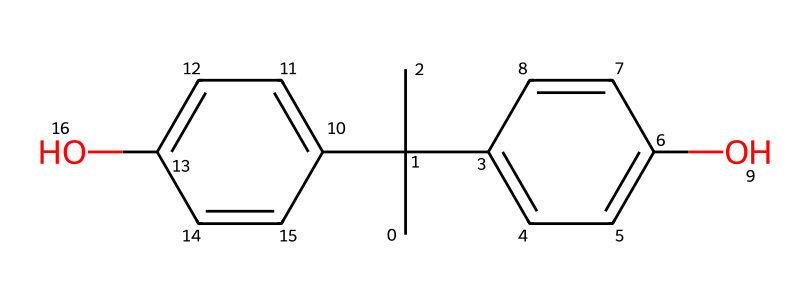what is the molecular formula of Bisphenol A? To determine the molecular formula, we can count the different atoms represented in the SMILES structure. There are 15 carbon (C) atoms, 16 hydrogen (H) atoms, and 2 oxygen (O) atoms. Thus, the molecular formula is C15H16O2.
Answer: C15H16O2 how many hydroxyl (–OH) groups are present in Bisphenol A? Looking at the SMILES representation, we can identify the hydroxyl groups by locating the "O" connected to "C" and looking for hydrogen atoms. There are two such groups in the structure.
Answer: 2 what type of chemical structure is represented by Bisphenol A? Bisphenol A has a phenolic structure due to the presence of benzene rings and hydroxyl groups. This characteristic allows it to be classified as a bisphenol.
Answer: bisphenol how many rings are present in the chemical structure? By analyzing the SMILES notation, we recognize there are two benzene rings, each making a complete cycle of bonds. Therefore, there are 2 rings in total.
Answer: 2 why is Bisphenol A significant in the production of polycarbonate plastics? Bisphenol A is significant due to its ability to polymerize, forming strong covalent bonds that create durable and heat-resistant materials, which are key properties for polycarbonate plastics.
Answer: polymerization how many double bonds are present in Bisphenol A? In examining the chemical structure, we find that there are two double bonds within the two benzene rings forming part of the compound, indicating the presence of 2 double bonds.
Answer: 2 